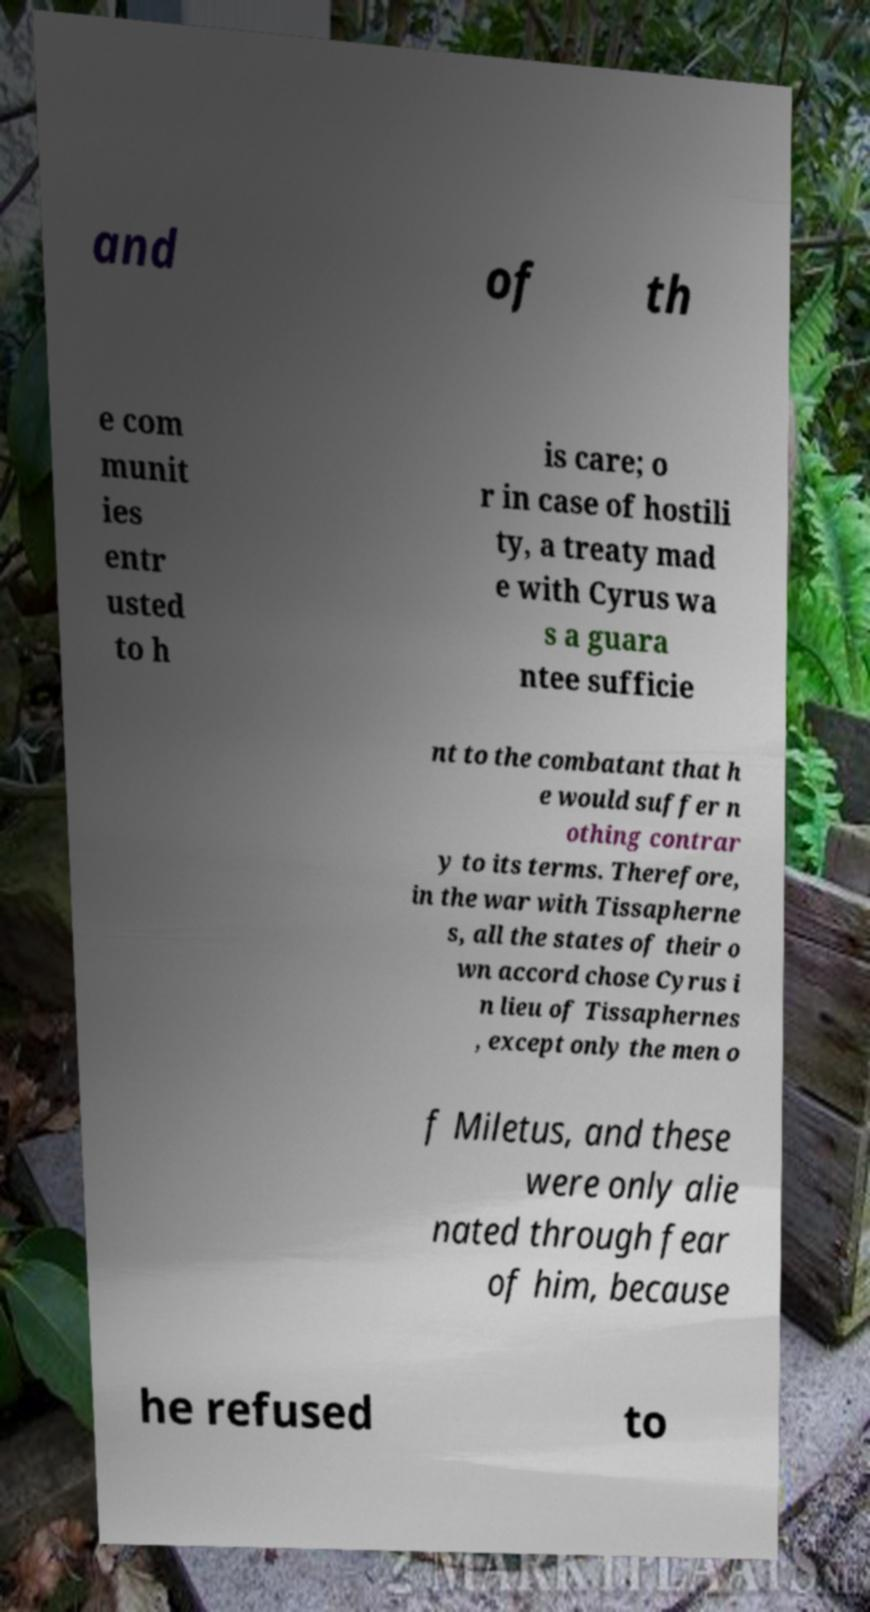Can you accurately transcribe the text from the provided image for me? and of th e com munit ies entr usted to h is care; o r in case of hostili ty, a treaty mad e with Cyrus wa s a guara ntee sufficie nt to the combatant that h e would suffer n othing contrar y to its terms. Therefore, in the war with Tissapherne s, all the states of their o wn accord chose Cyrus i n lieu of Tissaphernes , except only the men o f Miletus, and these were only alie nated through fear of him, because he refused to 